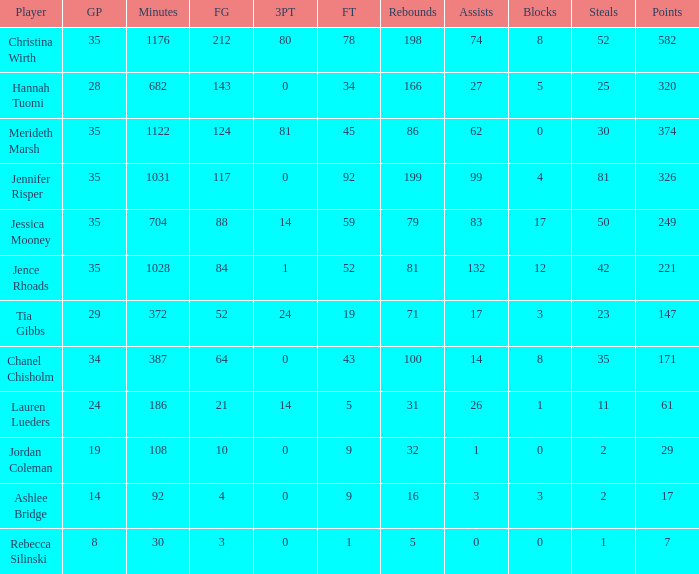Over what period of time did jordan coleman participate in playing? 108.0. 